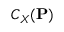<formula> <loc_0><loc_0><loc_500><loc_500>C _ { X } ( P )</formula> 